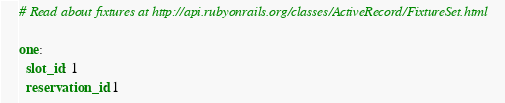Convert code to text. <code><loc_0><loc_0><loc_500><loc_500><_YAML_># Read about fixtures at http://api.rubyonrails.org/classes/ActiveRecord/FixtureSet.html

one:
  slot_id: 1
  reservation_id: 1</code> 